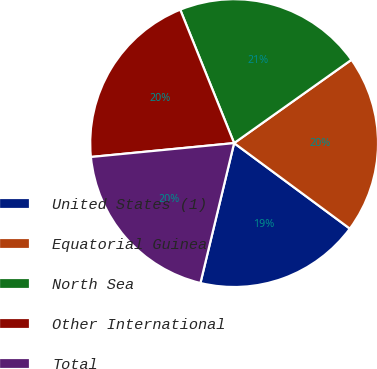Convert chart to OTSL. <chart><loc_0><loc_0><loc_500><loc_500><pie_chart><fcel>United States (1)<fcel>Equatorial Guinea<fcel>North Sea<fcel>Other International<fcel>Total<nl><fcel>18.63%<fcel>19.96%<fcel>21.28%<fcel>20.43%<fcel>19.7%<nl></chart> 